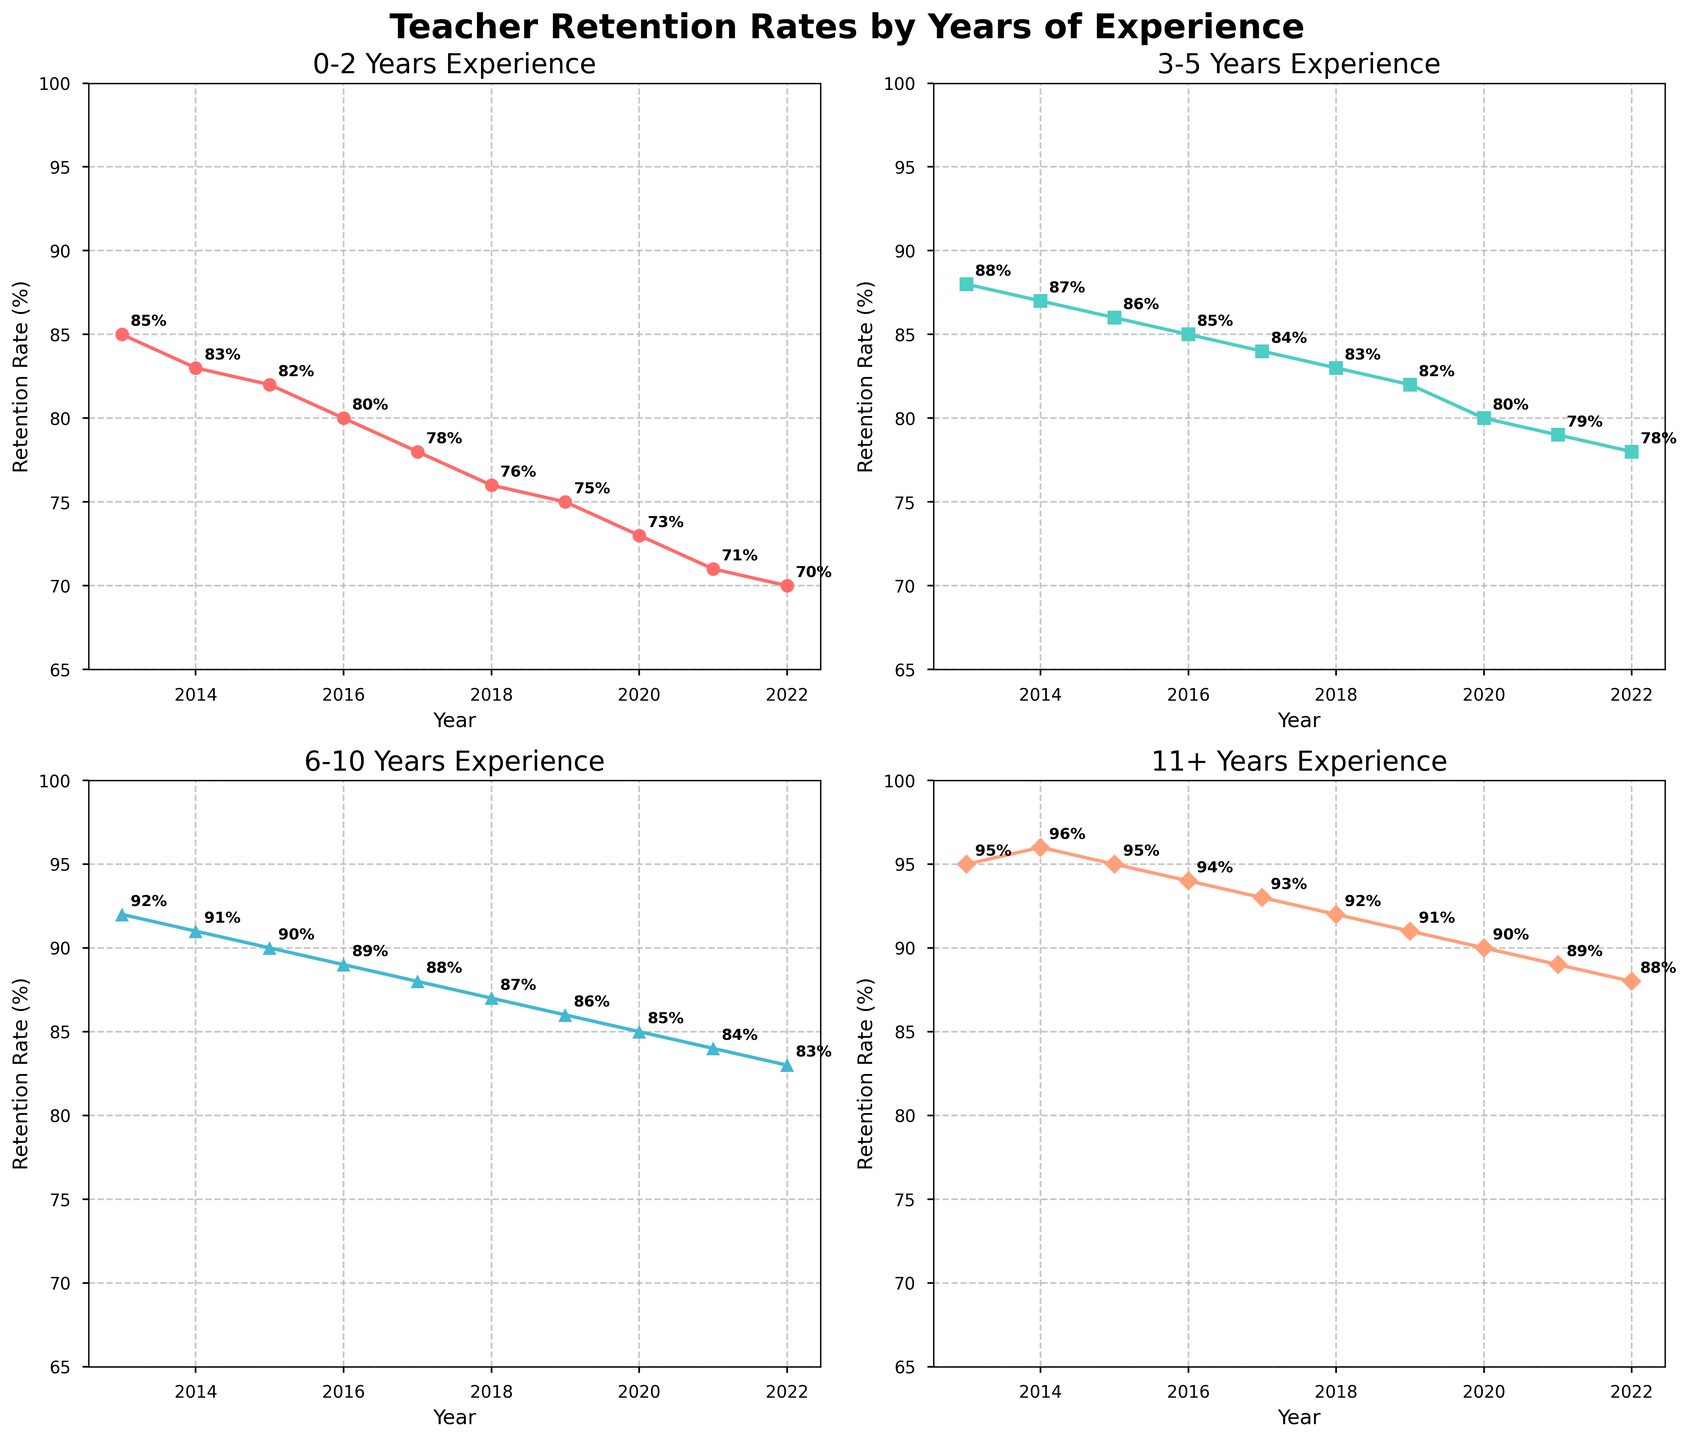what's the difference in retention rates for teachers with 0-2 years of experience between 2013 and 2022? Look at the line plot for 0-2 years of experience. In 2013, the retention rate is 85%. In 2022, it is 70%. Subtract the 2022 value from the 2013 value: 85% - 70% = 15%.
Answer: 15% Which group had the highest retention rate in 2015? Compare the retention rates of all four groups in the subplot for 2015. The values are as follows: 0-2 years: 82%, 3-5 years: 86%, 6-10 years: 90%, 11+ years: 95%. The highest value is 95% for the 11+ years experience group.
Answer: 11+ years experience What is the average retention rate for teachers with 6-10 years of experience from 2013 to 2017? Observe the values for 6-10 years of experience: 2013: 92%, 2014: 91%, 2015: 90%, 2016: 89%, 2017: 88%. Add these values: 92 + 91 + 90 + 89 + 88 = 450. Divide by 5 to get the average: 450 / 5 = 90%.
Answer: 90% Which year saw the steepest decline in retention rates for teachers with 3-5 years of experience? Check the year-over-year decrease in the 3-5 years experience group. The differences are: 2013-2014: 1%, 2014-2015: 1%, 2015-2016: 1%, 2016-2017: 1%, 2017-2018: 1%. They all decline by 1%, so there is no single steepest decline year; the decline is consistent year-over-year.
Answer: Consistent By how much did the retention rate for teachers with 11+ years of experience change from 2013 to 2020? Look at the line plot for 11+ years of experience. In 2013, the rate is 95%. In 2020, it's 90%. Subtract the 2020 value from the 2013 value: 95% - 90% = 5%.
Answer: 5% How did the retention rate trend for teachers with 0-2 years of experience compare to that of teachers with 11+ years of experience? Observe the overall trendlines for both groups from 2013 to 2022. 0-2 years experience shows a steady decline from 85% to 70%. The 11+ years experience group also declines but at a slightly reduced rate from 95% to 88%.
Answer: Both decline, 0-2 years declines more steeply What's the total retention rate for teachers with 3-5 years of experience over the given timeframe? Sum the retention rates for the 3-5 years group across all years: 88 + 87 + 86 + 85 + 84 + 83 + 82 + 80 + 79 + 78 = 832%.
Answer: 832% Which group showed the least amount of change in their retention rate over the decade? Calculate the difference between the first and last years' retention rates for all groups: 0-2 years: 85% - 70% = 15%, 3-5 years: 88% - 78% = 10%, 6-10 years: 92% - 83% = 9%, 11+ years: 95% - 88% = 7%. The group with 11+ years of experience showed the least change.
Answer: 11+ years experience What was the retention rate for teachers with 6-10 years of experience in 2016, and how does it compare to the rate for 0-2 years of experience in the same year? Look at the rates for both groups in 2016: 6-10 years experience is 89%, 0-2 years experience is 80%. The difference is 89% - 80% = 9%.
Answer: 9% What is the ratio of retention rates between teachers with 6-10 years and those with 0-2 years of experience in 2022? Divide the retention rate of 6-10 years by 0-2 years in 2022: 83% / 70% = 1.186.
Answer: 1.186 